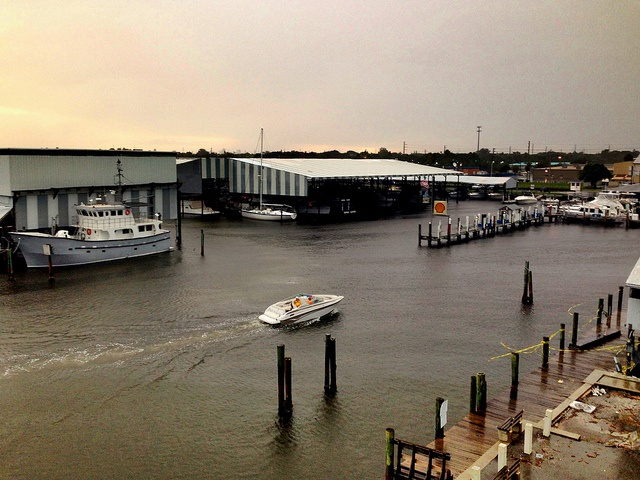Describe the objects in this image and their specific colors. I can see boat in beige, gray, black, darkgray, and lightgray tones, boat in beige, darkgray, black, and gray tones, boat in beige, black, gray, darkgray, and lightgray tones, boat in beige, black, gray, maroon, and darkgray tones, and boat in beige, black, gray, and darkgray tones in this image. 